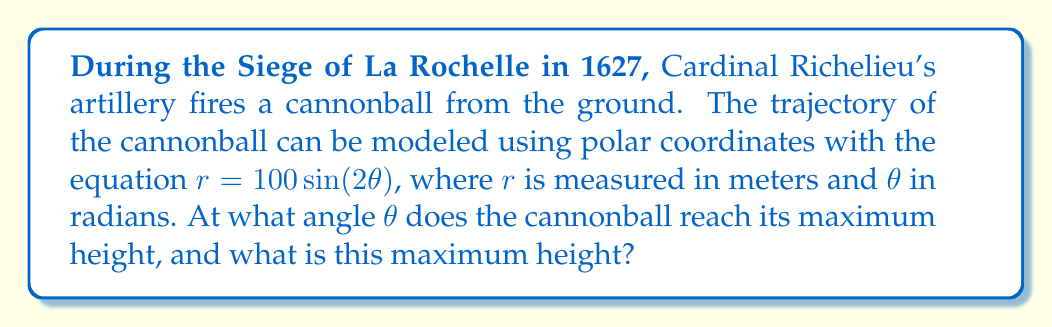Solve this math problem. To solve this problem, we'll follow these steps:

1) In polar coordinates, the maximum height occurs when $\frac{dr}{d\theta} = 0$.

2) We start by differentiating $r$ with respect to $\theta$:

   $$\frac{dr}{d\theta} = 100 \cdot 2 \cos(2\theta) = 200 \cos(2\theta)$$

3) Set this equal to zero and solve for $\theta$:

   $$200 \cos(2\theta) = 0$$
   $$\cos(2\theta) = 0$$

4) The cosine function equals zero when its argument is an odd multiple of $\frac{\pi}{2}$. The smallest positive solution is:

   $$2\theta = \frac{\pi}{2}$$
   $$\theta = \frac{\pi}{4} = 45^\circ$$

5) To find the maximum height, we substitute this value of $\theta$ back into the original equation:

   $$r = 100 \sin(2 \cdot \frac{\pi}{4}) = 100 \sin(\frac{\pi}{2}) = 100$$

6) However, this $r$ value represents the distance from the origin to the cannonball along the line at angle $\theta$. To find the vertical height, we need to calculate $r \sin(\theta)$:

   $$\text{Height} = r \sin(\theta) = 100 \sin(\frac{\pi}{4}) = 100 \cdot \frac{\sqrt{2}}{2} = 50\sqrt{2} \approx 70.71 \text{ meters}$$

[asy]
import graph;
size(200);
real f(real t) {return 100*sin(2*t);}
draw(polargraph(f,0,pi/2,operator ..),blue);
draw((0,0)--(50*sqrt(2),50*sqrt(2)),red,Arrow);
label("$r=100$",(50*sqrt(2),50*sqrt(2)),NE);
label("$\theta=\frac{\pi}{4}$",(25,0),S);
dot((0,0));
dot((50*sqrt(2),50*sqrt(2)));
[/asy]
Answer: The cannonball reaches its maximum height at an angle of $\theta = \frac{\pi}{4}$ radians or $45^\circ$, and the maximum height is $50\sqrt{2} \approx 70.71$ meters. 